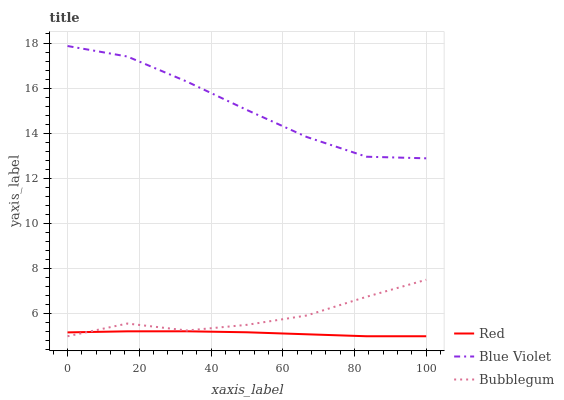Does Red have the minimum area under the curve?
Answer yes or no. Yes. Does Blue Violet have the maximum area under the curve?
Answer yes or no. Yes. Does Blue Violet have the minimum area under the curve?
Answer yes or no. No. Does Red have the maximum area under the curve?
Answer yes or no. No. Is Red the smoothest?
Answer yes or no. Yes. Is Bubblegum the roughest?
Answer yes or no. Yes. Is Blue Violet the smoothest?
Answer yes or no. No. Is Blue Violet the roughest?
Answer yes or no. No. Does Bubblegum have the lowest value?
Answer yes or no. Yes. Does Blue Violet have the lowest value?
Answer yes or no. No. Does Blue Violet have the highest value?
Answer yes or no. Yes. Does Red have the highest value?
Answer yes or no. No. Is Red less than Blue Violet?
Answer yes or no. Yes. Is Blue Violet greater than Red?
Answer yes or no. Yes. Does Red intersect Bubblegum?
Answer yes or no. Yes. Is Red less than Bubblegum?
Answer yes or no. No. Is Red greater than Bubblegum?
Answer yes or no. No. Does Red intersect Blue Violet?
Answer yes or no. No. 